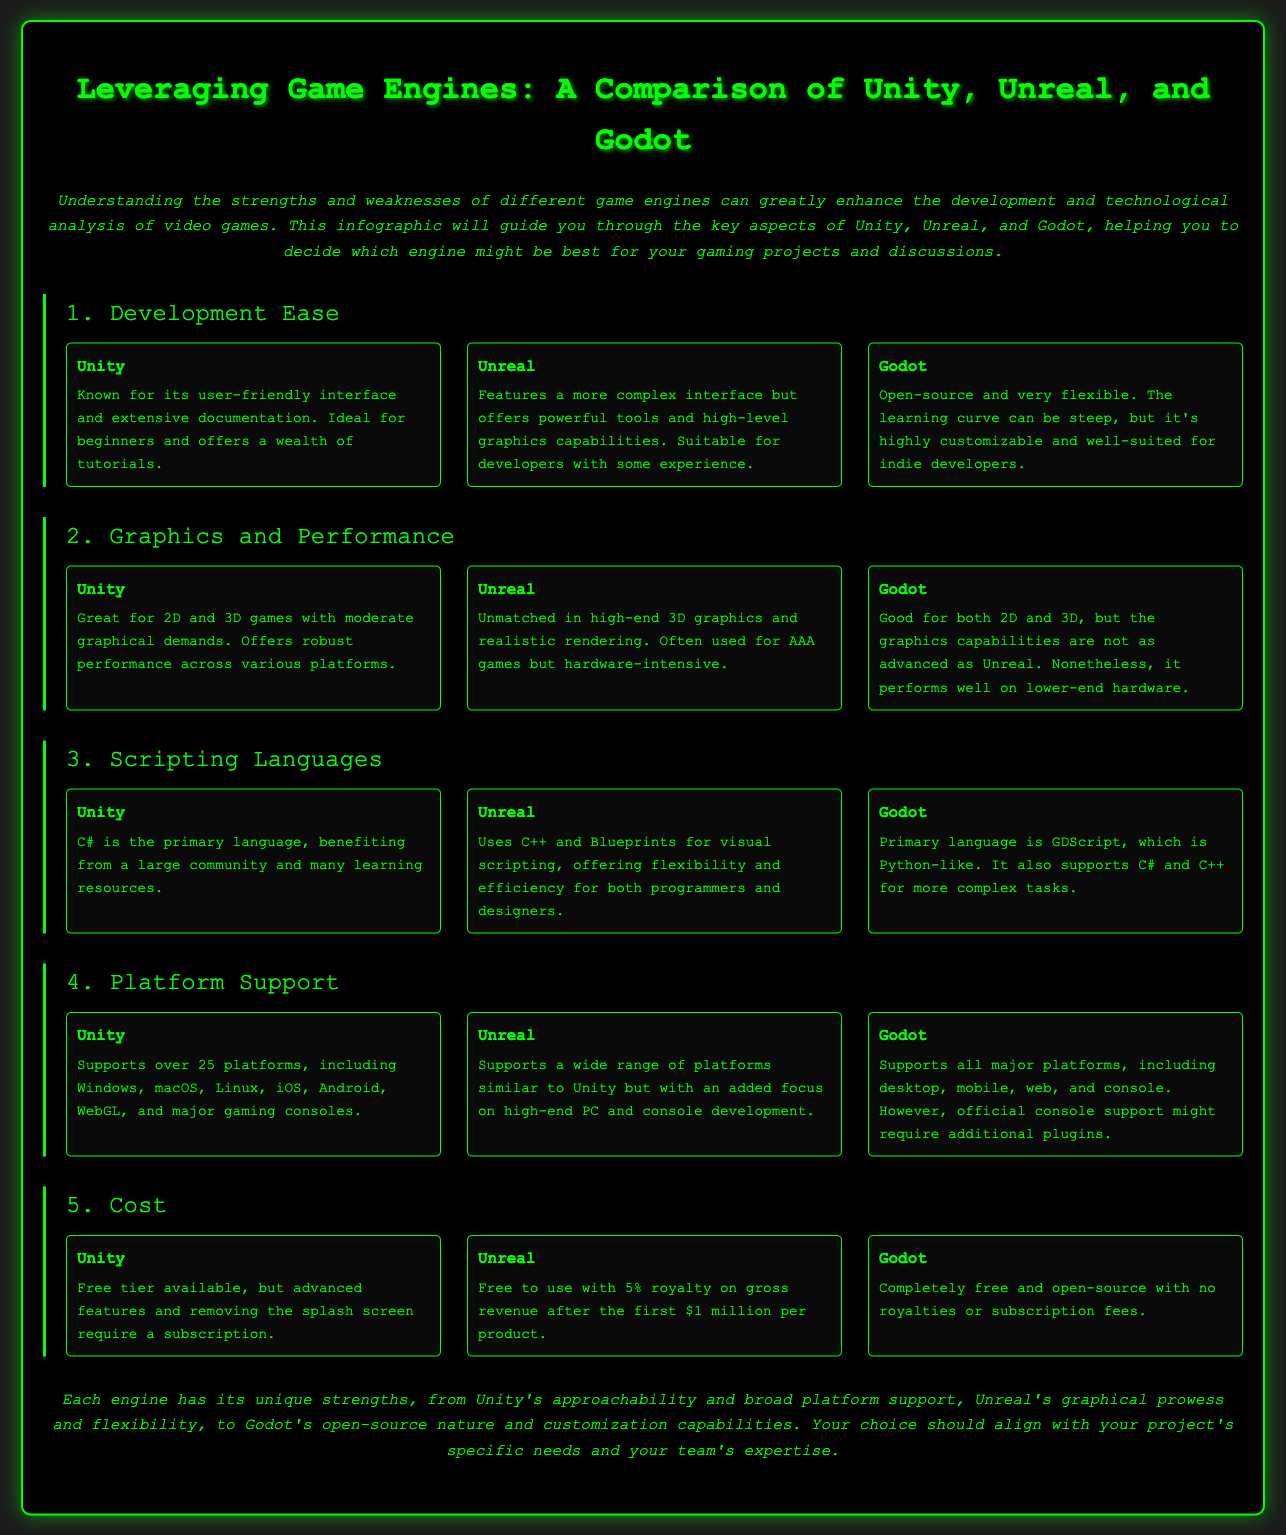What is the primary language used in Unity? Unity's primary scripting language is C#, as noted in the scripting languages section of the document.
Answer: C# Which game engine is known for high-end 3D graphics? The document states that Unreal is unmatched in high-end 3D graphics and realistic rendering.
Answer: Unreal What is Godot's licensing model? Godot is completely free and open-source with no royalties or subscription fees, as per the cost section.
Answer: Free How many platforms does Unity support? According to the platform support section, Unity supports over 25 platforms.
Answer: Over 25 Which engine is described as ideal for beginners? The document mentions that Unity is known for its user-friendly interface and extensive documentation, ideal for beginners.
Answer: Unity What percentage royalty does Unreal charge after the first million dollars? The document specifies that Unreal has a 5% royalty on gross revenue after the first $1 million per product.
Answer: 5% What is a unique feature of Godot reported in the document? The document highlights that Godot is open-source and highly customizable, which distinguishes it from the other engines.
Answer: Open-source What makes Unreal suitable for certain developers? Unreal offers powerful tools and high-level graphics capabilities, making it suitable for developers with some experience.
Answer: Experience What feature does Unity offer that requires a subscription? Advanced features and removing the splash screen in Unity require a subscription, as mentioned in the cost section.
Answer: Subscription 